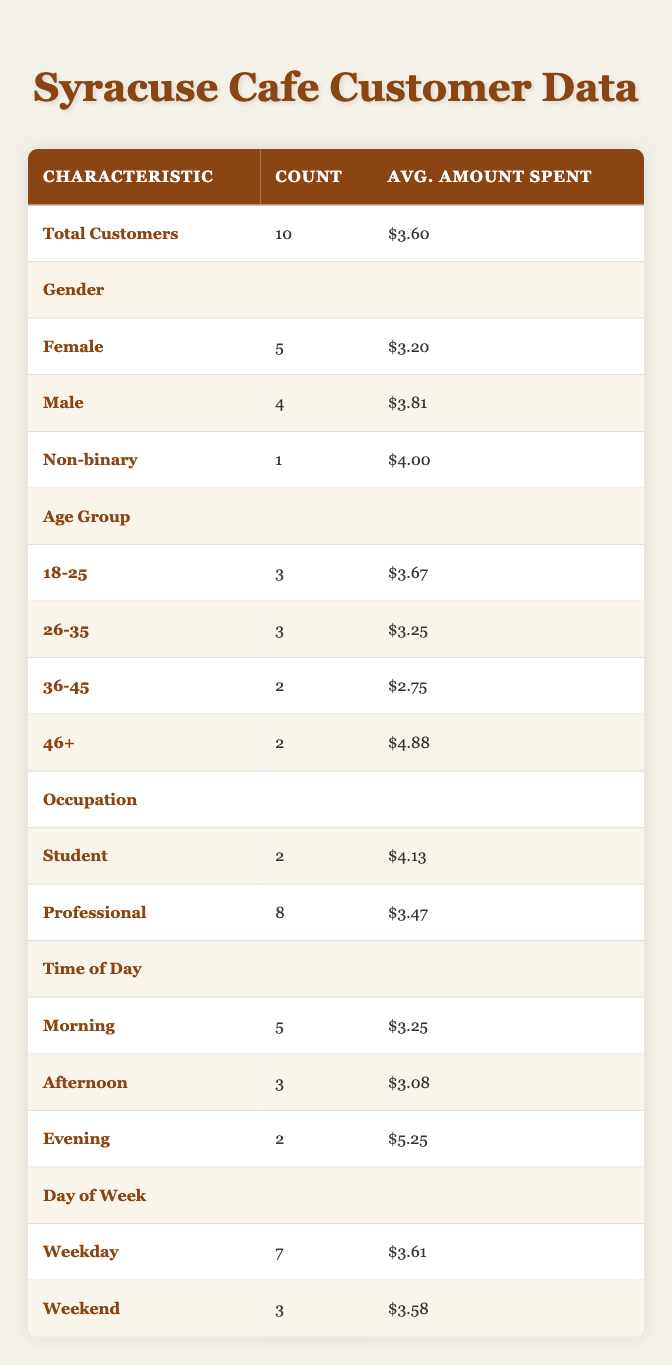What is the total number of customers? The table shows a row labeled "Total Customers" under the overall totals section. The count associated with that row is 10.
Answer: 10 What is the average amount spent by male customers? From the gender section, there are 4 male customers with an average amount spent listed as $3.81.
Answer: $3.81 How many customers visited during the morning? In the time of day section, the row for "Morning" indicates that 5 customers visited during that time.
Answer: 5 What is the average amount spent by the age group 46 and older? Looking at the age group section, there are 2 customers aged 46+, and the average amount spent by them is reported as $4.88.
Answer: $4.88 Is the average spending of students higher than that of professionals? The average spending for students is $4.13, and for professionals, it is $3.47. Since $4.13 is greater than $3.47, the answer is yes.
Answer: Yes What is the total number of weekend customers? The day of the week section shows that there are 3 customers classified under "Weekend."
Answer: 3 What is the average amount spent by customers visiting on weekdays? The weekday section indicates there are 7 customers with an average amount spent of $3.61.
Answer: $3.61 Which gender group has the lowest average spending? The averages for gender show that female customers have an average of $3.20, male customers have $3.81, and non-binary customers have $4.00. Since $3.20 is the lowest, the answer is female.
Answer: Female What is the total amount spent by all customers who are professionals? The professional group has 8 customers, with an average spending of $3.47. Therefore, the total amount spent is 8 x $3.47 = $27.76.
Answer: $27.76 